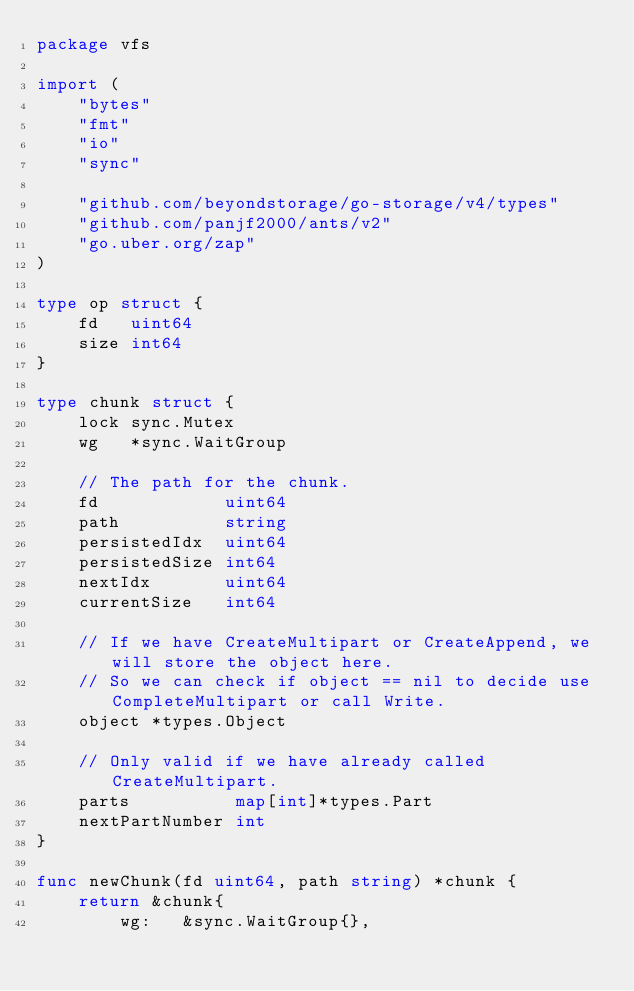Convert code to text. <code><loc_0><loc_0><loc_500><loc_500><_Go_>package vfs

import (
	"bytes"
	"fmt"
	"io"
	"sync"

	"github.com/beyondstorage/go-storage/v4/types"
	"github.com/panjf2000/ants/v2"
	"go.uber.org/zap"
)

type op struct {
	fd   uint64
	size int64
}

type chunk struct {
	lock sync.Mutex
	wg   *sync.WaitGroup

	// The path for the chunk.
	fd            uint64
	path          string
	persistedIdx  uint64
	persistedSize int64
	nextIdx       uint64
	currentSize   int64

	// If we have CreateMultipart or CreateAppend, we will store the object here.
	// So we can check if object == nil to decide use CompleteMultipart or call Write.
	object *types.Object

	// Only valid if we have already called CreateMultipart.
	parts          map[int]*types.Part
	nextPartNumber int
}

func newChunk(fd uint64, path string) *chunk {
	return &chunk{
		wg:   &sync.WaitGroup{},</code> 